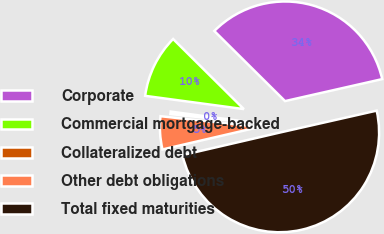Convert chart to OTSL. <chart><loc_0><loc_0><loc_500><loc_500><pie_chart><fcel>Corporate<fcel>Commercial mortgage-backed<fcel>Collateralized debt<fcel>Other debt obligations<fcel>Total fixed maturities<nl><fcel>34.03%<fcel>10.3%<fcel>0.4%<fcel>5.35%<fcel>49.92%<nl></chart> 